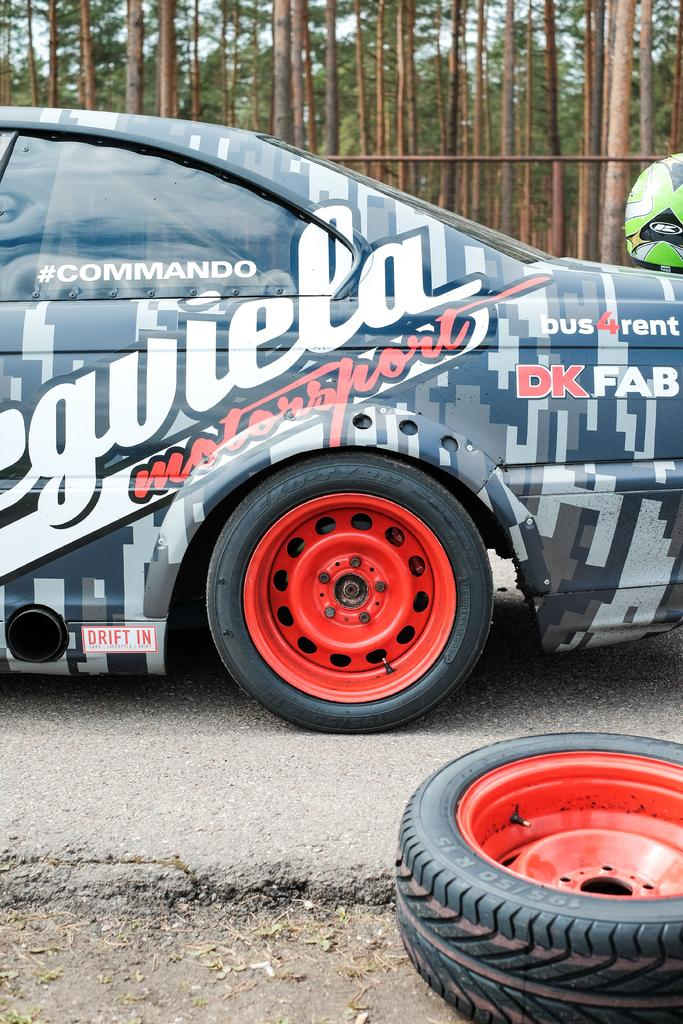What is the main subject of the image? The main subject of the image is a car. Can you describe any specific features on the car? Yes, there is writing on the car and a helmet on it. What can be seen in the background of the image? There are trees in the background of the image. What type of paint is being used to treat patients at the hospital in the image? There is no hospital or paint present in the image; it features a car with writing and a helmet. 